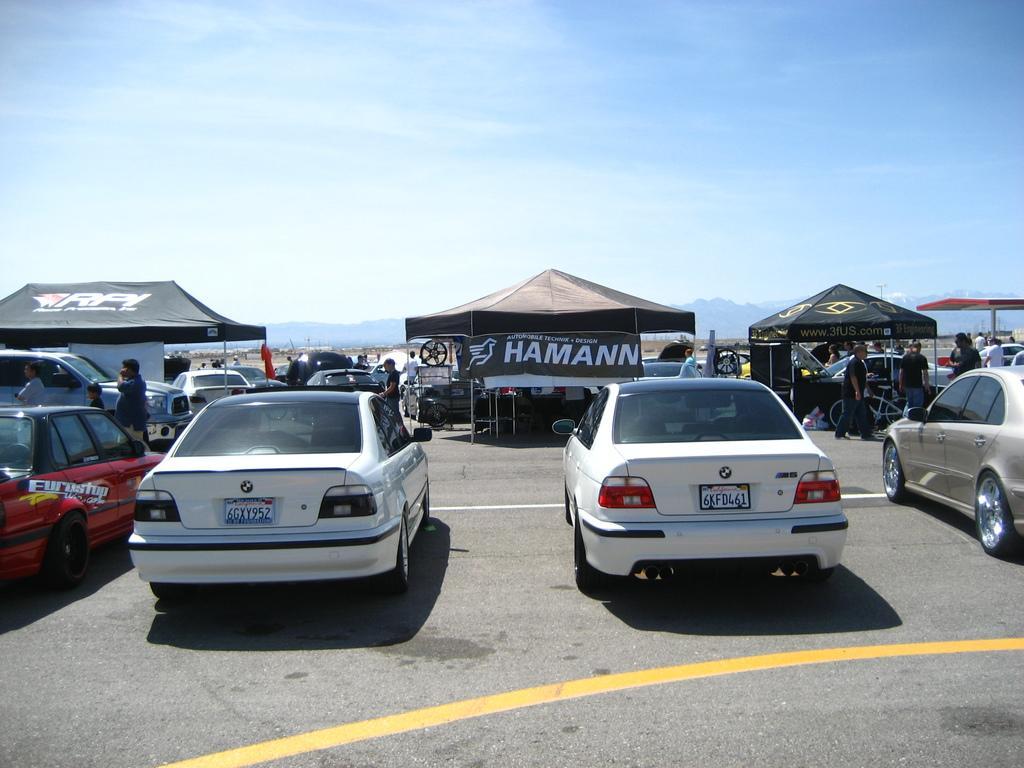Describe this image in one or two sentences. In this picture we can see cars on the road, tents, banner and a group of people where some are standing and some are walking, mountains and in the background we can see the sky with clouds. 